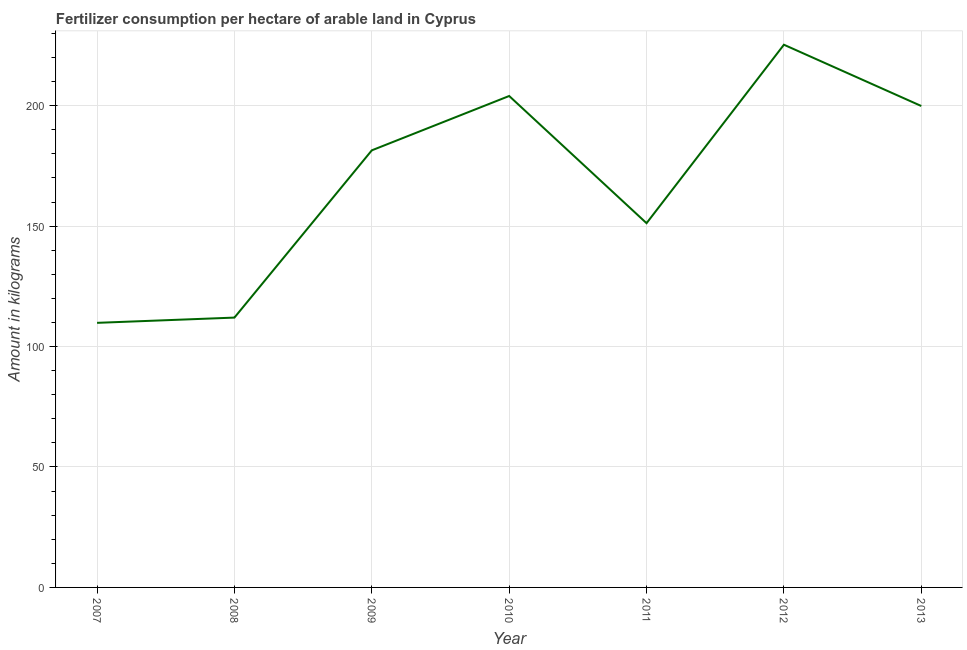What is the amount of fertilizer consumption in 2007?
Keep it short and to the point. 109.84. Across all years, what is the maximum amount of fertilizer consumption?
Make the answer very short. 225.29. Across all years, what is the minimum amount of fertilizer consumption?
Provide a short and direct response. 109.84. What is the sum of the amount of fertilizer consumption?
Provide a succinct answer. 1183.65. What is the difference between the amount of fertilizer consumption in 2011 and 2012?
Your answer should be compact. -74.08. What is the average amount of fertilizer consumption per year?
Provide a succinct answer. 169.09. What is the median amount of fertilizer consumption?
Your answer should be compact. 181.45. What is the ratio of the amount of fertilizer consumption in 2008 to that in 2010?
Keep it short and to the point. 0.55. Is the amount of fertilizer consumption in 2008 less than that in 2010?
Offer a very short reply. Yes. What is the difference between the highest and the second highest amount of fertilizer consumption?
Your response must be concise. 21.28. Is the sum of the amount of fertilizer consumption in 2012 and 2013 greater than the maximum amount of fertilizer consumption across all years?
Keep it short and to the point. Yes. What is the difference between the highest and the lowest amount of fertilizer consumption?
Make the answer very short. 115.45. In how many years, is the amount of fertilizer consumption greater than the average amount of fertilizer consumption taken over all years?
Offer a very short reply. 4. Does the amount of fertilizer consumption monotonically increase over the years?
Your answer should be compact. No. How many years are there in the graph?
Your response must be concise. 7. What is the difference between two consecutive major ticks on the Y-axis?
Your response must be concise. 50. Are the values on the major ticks of Y-axis written in scientific E-notation?
Your response must be concise. No. Does the graph contain any zero values?
Offer a very short reply. No. What is the title of the graph?
Offer a very short reply. Fertilizer consumption per hectare of arable land in Cyprus . What is the label or title of the Y-axis?
Keep it short and to the point. Amount in kilograms. What is the Amount in kilograms of 2007?
Your answer should be compact. 109.84. What is the Amount in kilograms of 2008?
Keep it short and to the point. 112.01. What is the Amount in kilograms of 2009?
Provide a short and direct response. 181.45. What is the Amount in kilograms in 2010?
Your answer should be compact. 204.01. What is the Amount in kilograms in 2011?
Your response must be concise. 151.2. What is the Amount in kilograms in 2012?
Offer a terse response. 225.29. What is the Amount in kilograms in 2013?
Provide a short and direct response. 199.85. What is the difference between the Amount in kilograms in 2007 and 2008?
Ensure brevity in your answer.  -2.18. What is the difference between the Amount in kilograms in 2007 and 2009?
Offer a very short reply. -71.61. What is the difference between the Amount in kilograms in 2007 and 2010?
Your answer should be compact. -94.17. What is the difference between the Amount in kilograms in 2007 and 2011?
Make the answer very short. -41.37. What is the difference between the Amount in kilograms in 2007 and 2012?
Provide a succinct answer. -115.45. What is the difference between the Amount in kilograms in 2007 and 2013?
Your answer should be very brief. -90.01. What is the difference between the Amount in kilograms in 2008 and 2009?
Your response must be concise. -69.44. What is the difference between the Amount in kilograms in 2008 and 2010?
Ensure brevity in your answer.  -91.99. What is the difference between the Amount in kilograms in 2008 and 2011?
Keep it short and to the point. -39.19. What is the difference between the Amount in kilograms in 2008 and 2012?
Provide a succinct answer. -113.27. What is the difference between the Amount in kilograms in 2008 and 2013?
Keep it short and to the point. -87.84. What is the difference between the Amount in kilograms in 2009 and 2010?
Give a very brief answer. -22.56. What is the difference between the Amount in kilograms in 2009 and 2011?
Offer a very short reply. 30.25. What is the difference between the Amount in kilograms in 2009 and 2012?
Your answer should be very brief. -43.84. What is the difference between the Amount in kilograms in 2009 and 2013?
Provide a succinct answer. -18.4. What is the difference between the Amount in kilograms in 2010 and 2011?
Your answer should be very brief. 52.8. What is the difference between the Amount in kilograms in 2010 and 2012?
Your answer should be compact. -21.28. What is the difference between the Amount in kilograms in 2010 and 2013?
Give a very brief answer. 4.16. What is the difference between the Amount in kilograms in 2011 and 2012?
Provide a succinct answer. -74.08. What is the difference between the Amount in kilograms in 2011 and 2013?
Your answer should be compact. -48.65. What is the difference between the Amount in kilograms in 2012 and 2013?
Make the answer very short. 25.44. What is the ratio of the Amount in kilograms in 2007 to that in 2008?
Keep it short and to the point. 0.98. What is the ratio of the Amount in kilograms in 2007 to that in 2009?
Make the answer very short. 0.6. What is the ratio of the Amount in kilograms in 2007 to that in 2010?
Keep it short and to the point. 0.54. What is the ratio of the Amount in kilograms in 2007 to that in 2011?
Your response must be concise. 0.73. What is the ratio of the Amount in kilograms in 2007 to that in 2012?
Provide a short and direct response. 0.49. What is the ratio of the Amount in kilograms in 2007 to that in 2013?
Make the answer very short. 0.55. What is the ratio of the Amount in kilograms in 2008 to that in 2009?
Provide a short and direct response. 0.62. What is the ratio of the Amount in kilograms in 2008 to that in 2010?
Give a very brief answer. 0.55. What is the ratio of the Amount in kilograms in 2008 to that in 2011?
Your answer should be very brief. 0.74. What is the ratio of the Amount in kilograms in 2008 to that in 2012?
Offer a very short reply. 0.5. What is the ratio of the Amount in kilograms in 2008 to that in 2013?
Offer a very short reply. 0.56. What is the ratio of the Amount in kilograms in 2009 to that in 2010?
Your answer should be very brief. 0.89. What is the ratio of the Amount in kilograms in 2009 to that in 2012?
Your answer should be compact. 0.81. What is the ratio of the Amount in kilograms in 2009 to that in 2013?
Provide a succinct answer. 0.91. What is the ratio of the Amount in kilograms in 2010 to that in 2011?
Your response must be concise. 1.35. What is the ratio of the Amount in kilograms in 2010 to that in 2012?
Give a very brief answer. 0.91. What is the ratio of the Amount in kilograms in 2011 to that in 2012?
Your answer should be compact. 0.67. What is the ratio of the Amount in kilograms in 2011 to that in 2013?
Offer a terse response. 0.76. What is the ratio of the Amount in kilograms in 2012 to that in 2013?
Offer a very short reply. 1.13. 